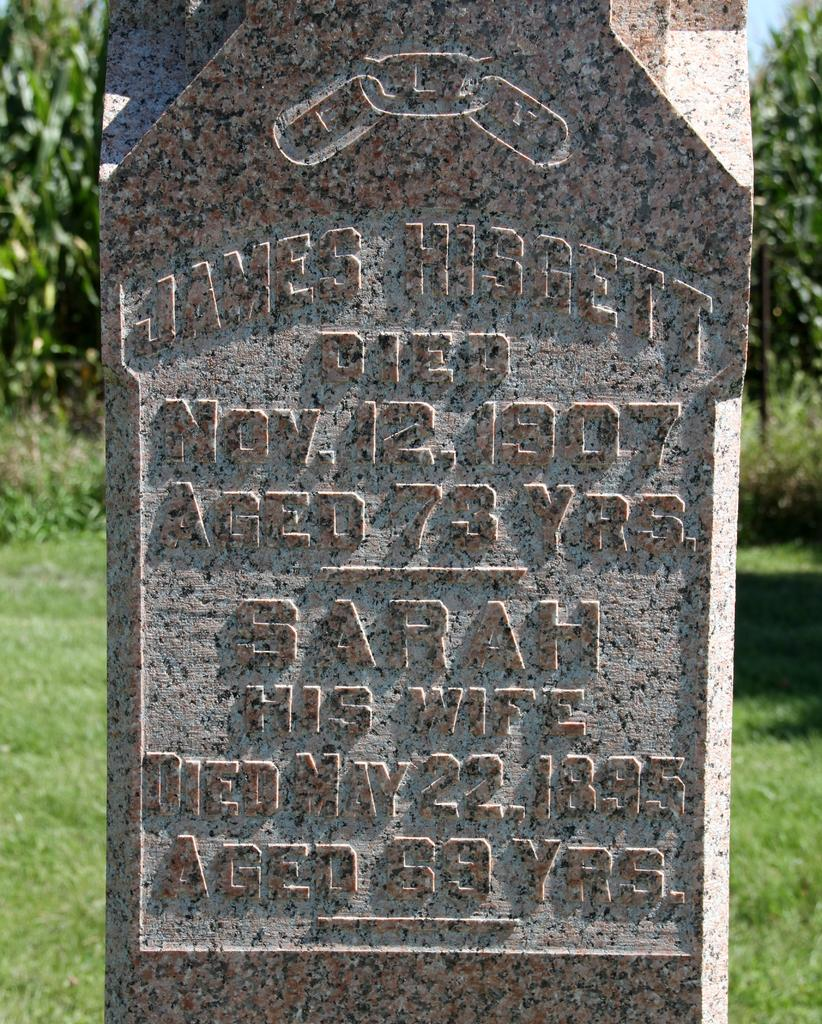What is the main subject in the center of the image? There is a headstone in the center of the image. What can be seen in the background of the image? There is greenery in the background of the image. What type of cord is attached to the headstone in the image? There is no cord attached to the headstone in the image. Can you see anyone running in the image? There are no people visible in the image, so it is impossible to determine if anyone is running. 